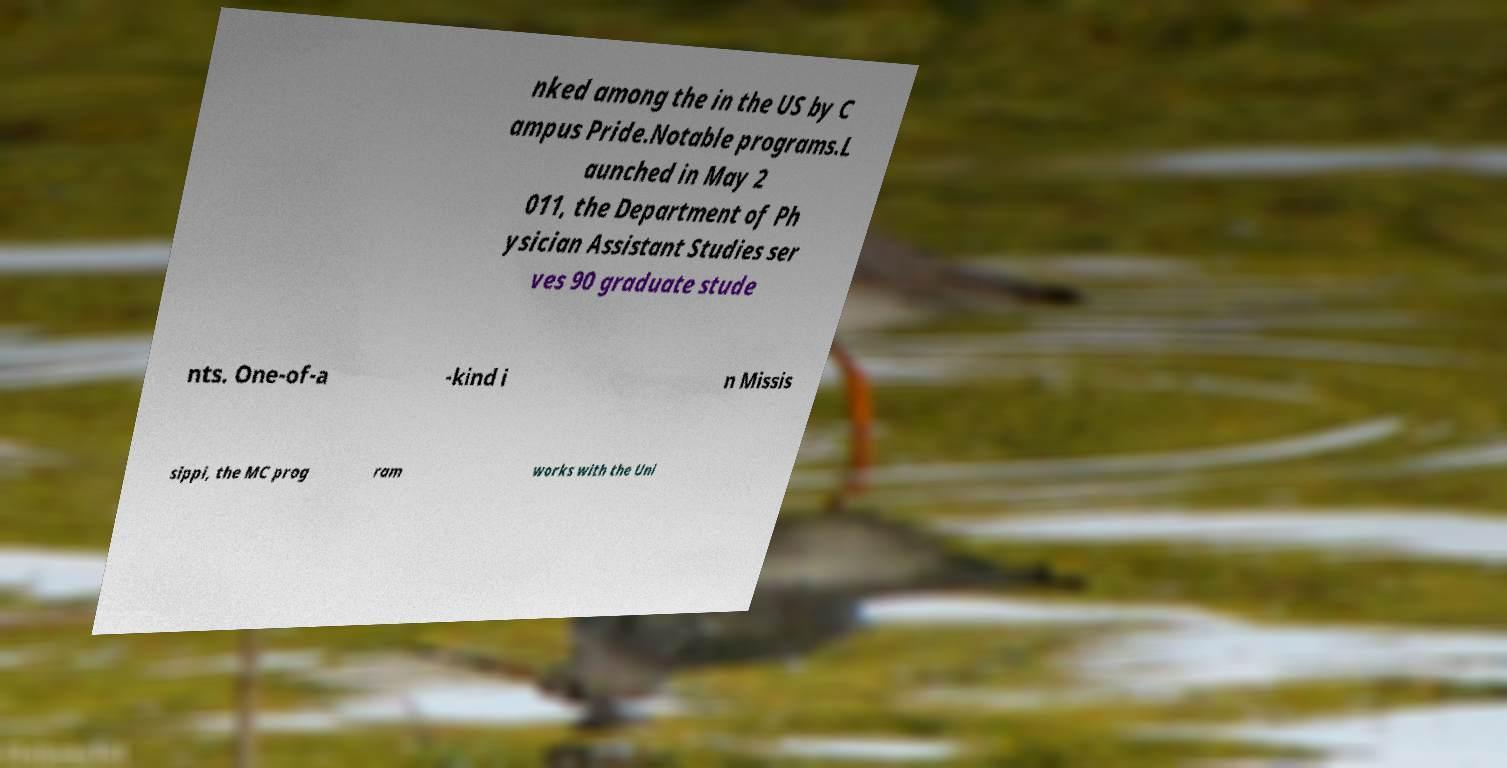There's text embedded in this image that I need extracted. Can you transcribe it verbatim? nked among the in the US by C ampus Pride.Notable programs.L aunched in May 2 011, the Department of Ph ysician Assistant Studies ser ves 90 graduate stude nts. One-of-a -kind i n Missis sippi, the MC prog ram works with the Uni 